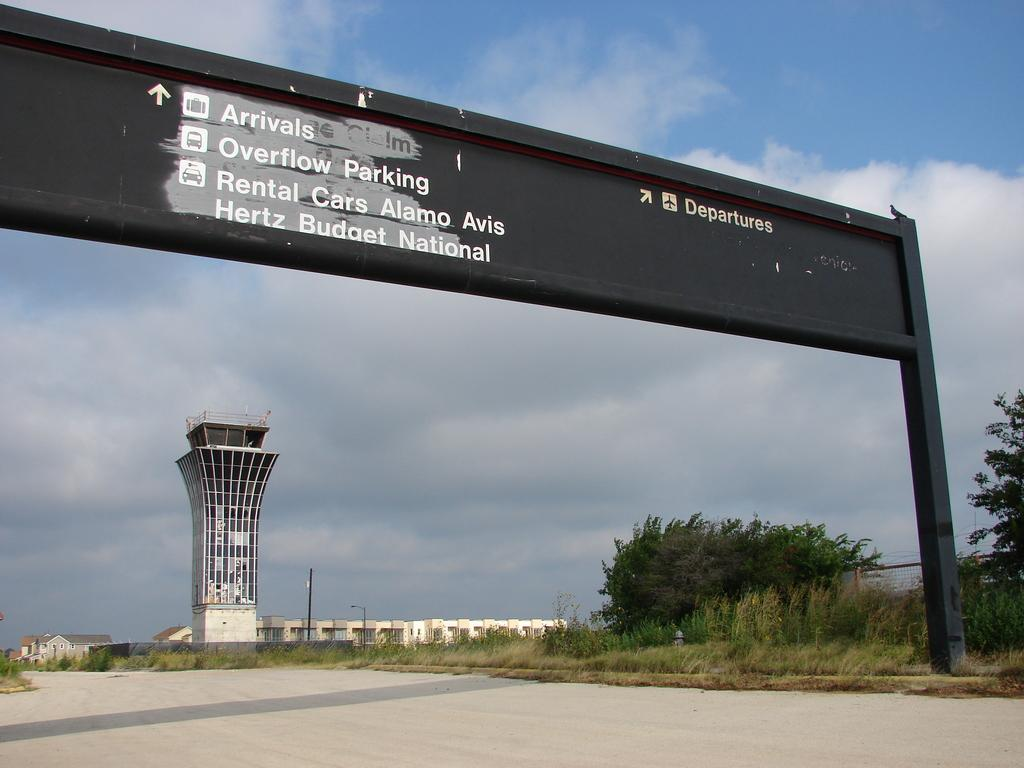<image>
Describe the image concisely. A sign gives directions to airport arrivals, departures, parking and rental cars. 